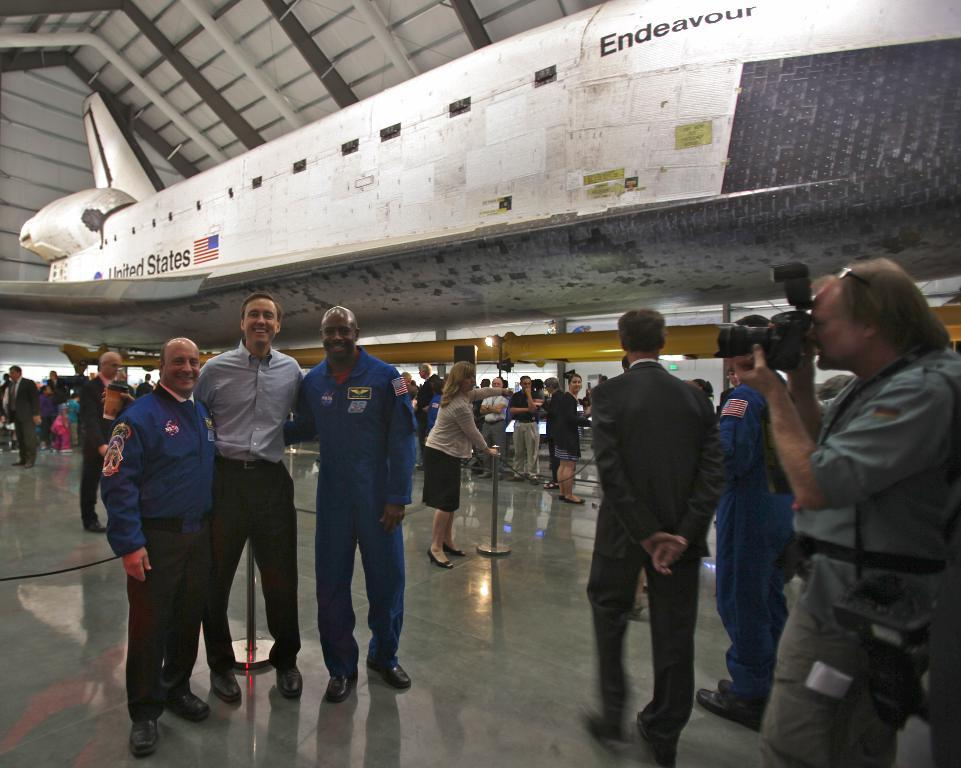<image>
Render a clear and concise summary of the photo. A group of men is photographed in front of the space shuttle Endeavour. 